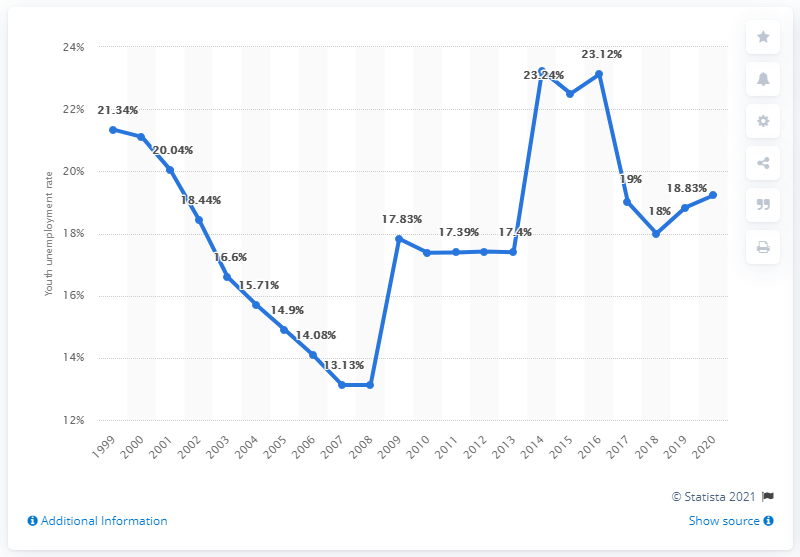Highlight a few significant elements in this photo. In 2020, the youth unemployment rate in Ukraine was 19.23%. 